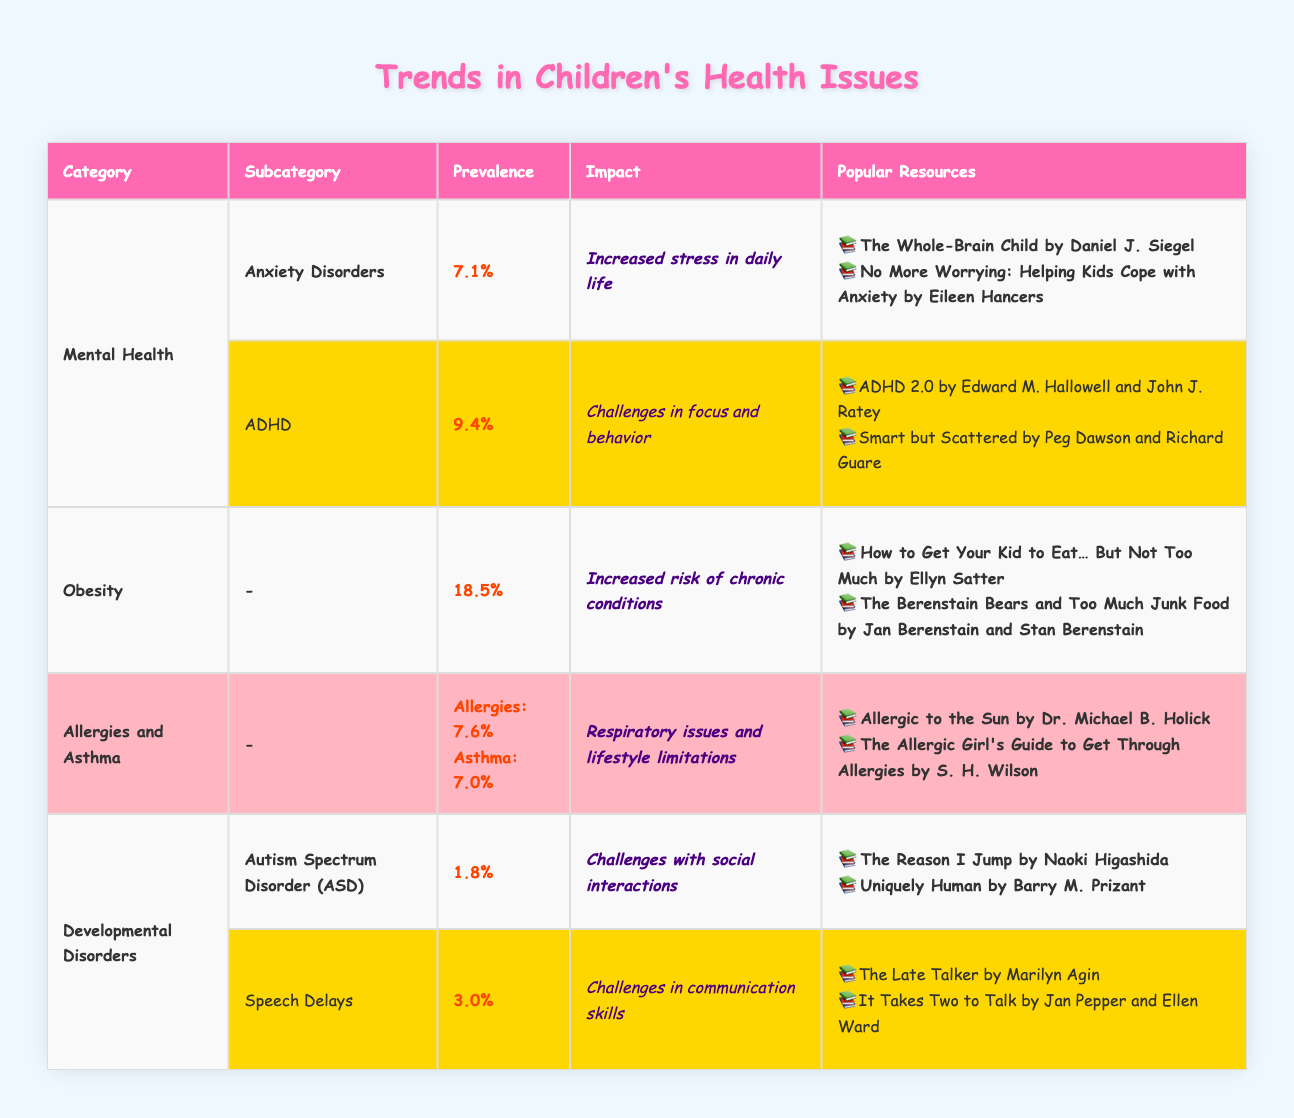What is the prevalence of Anxiety Disorders among children? The table lists the prevalence percentage of Anxiety Disorders under the Mental Health category, which is stated as 7.1%.
Answer: 7.1% Which children's health issue has the highest prevalence? By comparing the prevalence percentages in the table, Obesity is found to have the highest at 18.5%.
Answer: Obesity Is the impact of ADHD described as challenges in social interactions? The table indicates that ADHD's impact is challenges in focus and behavior, not social interactions, so the answer is false.
Answer: No What is the combined prevalence of Allergies and Asthma? The prevalence of Allergies is 7.6% and Asthma is 7.0%. Adding these gives 7.6% + 7.0% = 14.6%.
Answer: 14.6% What resources are suggested for dealing with Obesity? The popular resources for Obesity from the table are listed as "How to Get Your Kid to Eat… But Not Too Much" and "The Berenstain Bears and Too Much Junk Food."
Answer: How to Get Your Kid to Eat… But Not Too Much, The Berenstain Bears and Too Much Junk Food Which health issue has a prevalence of 3.0%? The category of Developmental Disorders includes Speech Delays which has a prevalence of 3.0%.
Answer: Speech Delays Does the table mention any book related to coping with Anxiety? Yes, the table lists "No More Worrying: Helping Kids Cope with Anxiety" as a resource for Anxiety Disorders, confirming that the statement is true.
Answer: Yes What is the impact of Autism Spectrum Disorder (ASD)? The table presents that the impact of Autism Spectrum Disorder (ASD) is described as challenges with social interactions.
Answer: Challenges with social interactions What is the average prevalence of the two developmental disorders listed? The two developmental disorders listed are Autism Spectrum Disorder (1.8%) and Speech Delays (3.0%). The average is calculated as (1.8% + 3.0%) / 2 = 2.4%.
Answer: 2.4% 